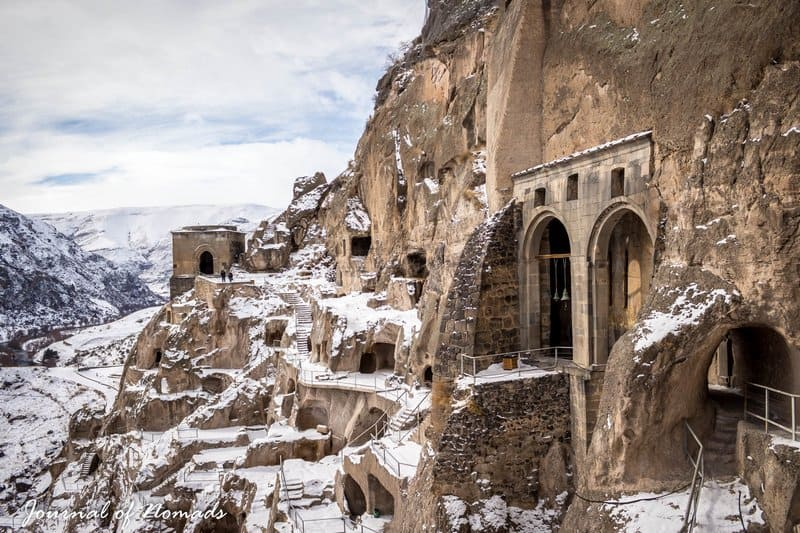What can you tell me about the history of the Vardzia cave monastery? Vardzia was excavated in the Erusheti Mountain in southern Georgia in the 12th century. Built by King George III and later expanded by Queen Tamar, it served as a fortification as well as a monastery. It was designed to be a hidden sanctuary in times of invasion and has a fascinating network of caves and tunnels. The site was a thriving center of religion and culture until it was largely abandoned after a devastating earthquake in the 13th century. 